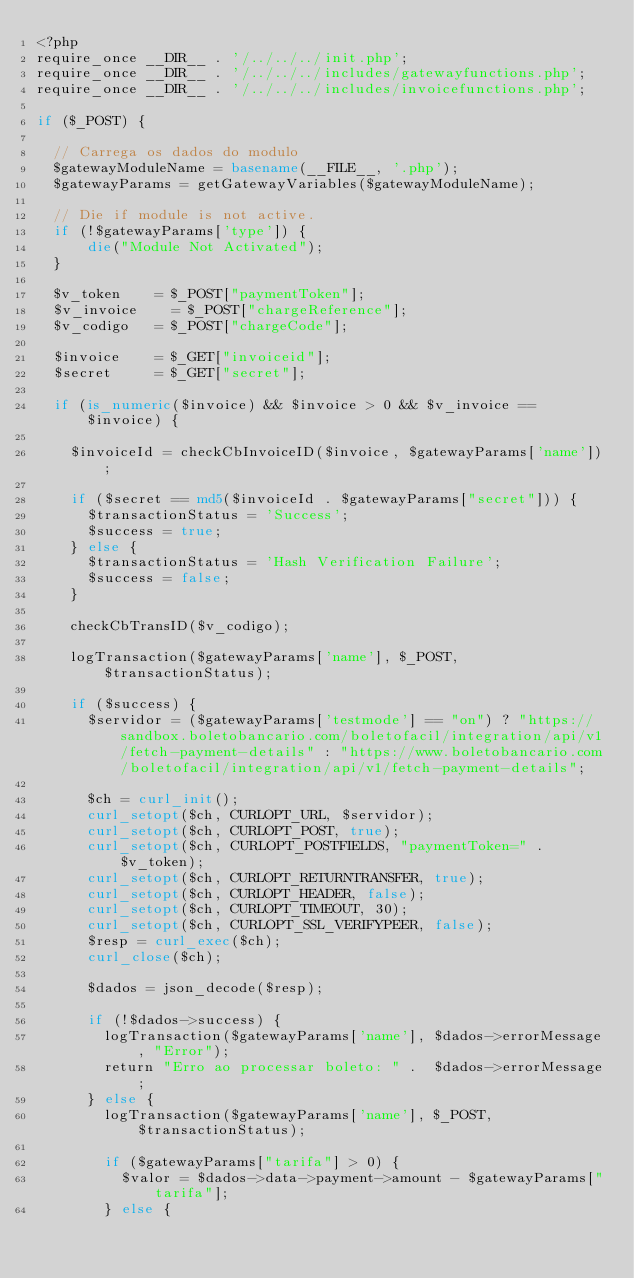<code> <loc_0><loc_0><loc_500><loc_500><_PHP_><?php
require_once __DIR__ . '/../../../init.php';
require_once __DIR__ . '/../../../includes/gatewayfunctions.php';
require_once __DIR__ . '/../../../includes/invoicefunctions.php';

if ($_POST) {
		
	// Carrega os dados do modulo
	$gatewayModuleName = basename(__FILE__, '.php');
	$gatewayParams = getGatewayVariables($gatewayModuleName);

	// Die if module is not active.
	if (!$gatewayParams['type']) {
	    die("Module Not Activated");
	}
		
	$v_token 		= $_POST["paymentToken"];
	$v_invoice 		= $_POST["chargeReference"];
	$v_codigo		= $_POST["chargeCode"];

	$invoice		= $_GET["invoiceid"];
	$secret			= $_GET["secret"];
	
	if (is_numeric($invoice) && $invoice > 0 && $v_invoice == $invoice) {

		$invoiceId = checkCbInvoiceID($invoice, $gatewayParams['name']);

		if ($secret == md5($invoiceId . $gatewayParams["secret"])) {
			$transactionStatus = 'Success';
			$success = true;
		} else {
			$transactionStatus = 'Hash Verification Failure';
			$success = false;
		}
			
		checkCbTransID($v_codigo);
		
		logTransaction($gatewayParams['name'], $_POST, $transactionStatus);
		
		if ($success) {
			$servidor = ($gatewayParams['testmode'] == "on") ? "https://sandbox.boletobancario.com/boletofacil/integration/api/v1/fetch-payment-details" : "https://www.boletobancario.com/boletofacil/integration/api/v1/fetch-payment-details";

			$ch = curl_init();
			curl_setopt($ch, CURLOPT_URL, $servidor);
			curl_setopt($ch, CURLOPT_POST, true);
			curl_setopt($ch, CURLOPT_POSTFIELDS, "paymentToken=" . $v_token);
			curl_setopt($ch, CURLOPT_RETURNTRANSFER, true);
			curl_setopt($ch, CURLOPT_HEADER, false);
			curl_setopt($ch, CURLOPT_TIMEOUT, 30);
			curl_setopt($ch, CURLOPT_SSL_VERIFYPEER, false);
			$resp = curl_exec($ch);
			curl_close($ch);			
	
			$dados = json_decode($resp);
			
			if (!$dados->success) {
				logTransaction($gatewayParams['name'], $dados->errorMessage, "Error");
				return "Erro ao processar boleto: " .  $dados->errorMessage;
			} else {
				logTransaction($gatewayParams['name'], $_POST, $transactionStatus);
				
				if ($gatewayParams["tarifa"] > 0) {
					$valor = $dados->data->payment->amount - $gatewayParams["tarifa"];
				} else {</code> 